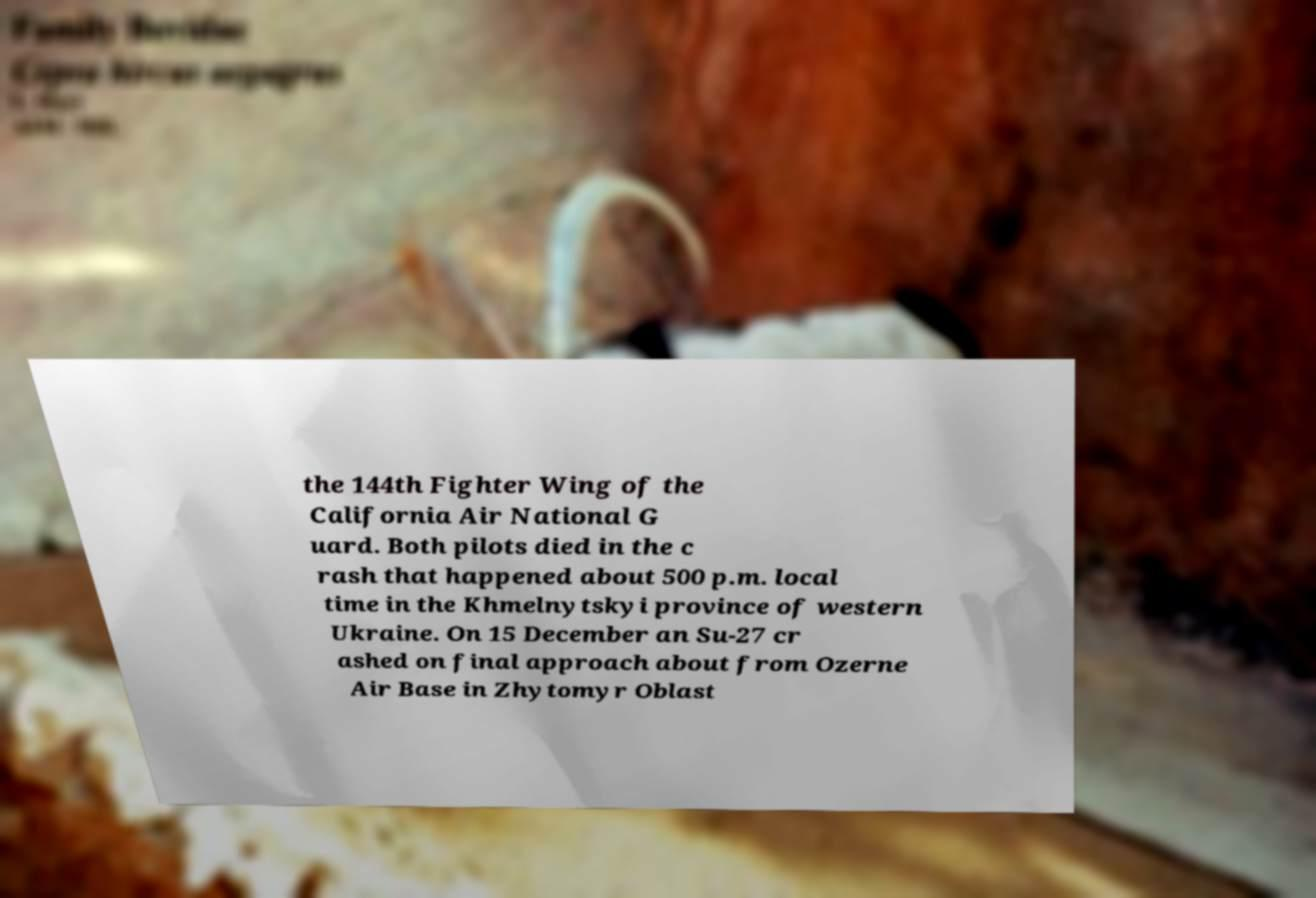Could you assist in decoding the text presented in this image and type it out clearly? the 144th Fighter Wing of the California Air National G uard. Both pilots died in the c rash that happened about 500 p.m. local time in the Khmelnytskyi province of western Ukraine. On 15 December an Su-27 cr ashed on final approach about from Ozerne Air Base in Zhytomyr Oblast 